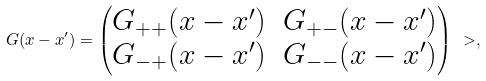<formula> <loc_0><loc_0><loc_500><loc_500>G ( x - x ^ { \prime } ) = \begin{pmatrix} G _ { + + } ( x - x ^ { \prime } ) & G _ { + - } ( x - x ^ { \prime } ) \\ G _ { - + } ( x - x ^ { \prime } ) & G _ { - - } ( x - x ^ { \prime } ) \end{pmatrix} \ > ,</formula> 